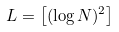<formula> <loc_0><loc_0><loc_500><loc_500>L = \left [ ( \log N ) ^ { 2 } \right ]</formula> 